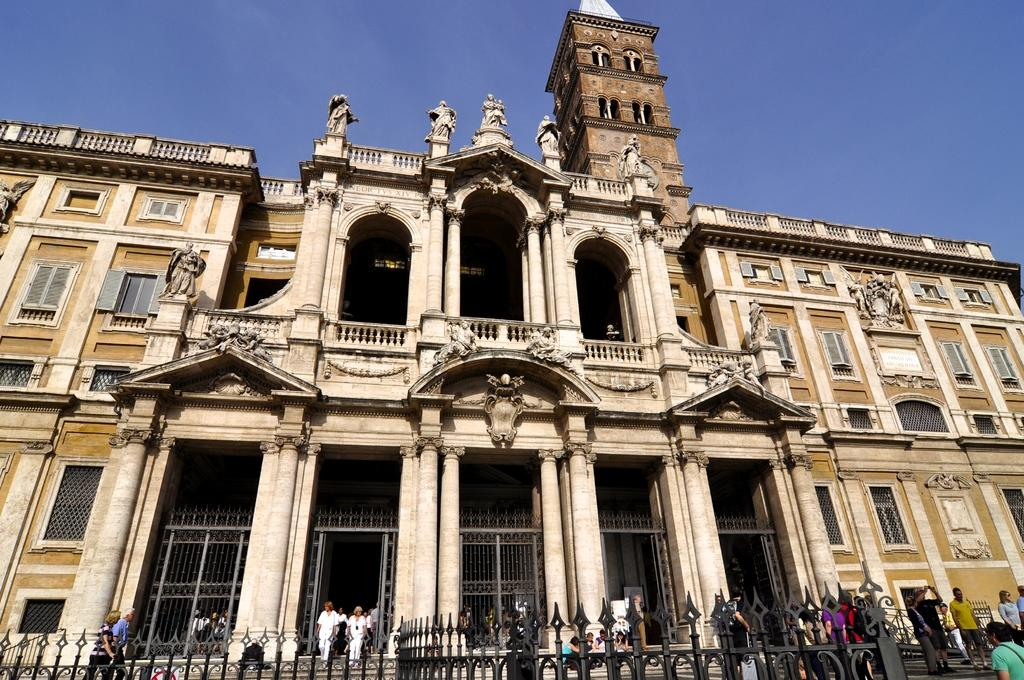What type of structure can be seen in the image? There is a building in the image. What is located near the building? There is a fence in the image. Who or what can be seen in the image? There are people in the image. Are there any other architectural features present in the image? Yes, there are pillars in the image. What can be seen inside the building? There are windows in the image, which suggests that there are rooms or spaces inside the building. What is visible in the background of the image? The sky is visible in the background of the image, and its color is blue. What month is it in the image? The month cannot be determined from the image, as it only shows a building, fence, people, pillars, windows, and a blue sky in the background. Is there a hospital visible in the image? No, there is no hospital present in the image. 